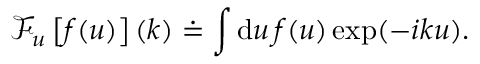<formula> <loc_0><loc_0><loc_500><loc_500>\mathcal { F } _ { u } \left [ f ( u ) \right ] ( k ) \doteq \int d u \, f ( u ) \exp ( - i k u ) .</formula> 